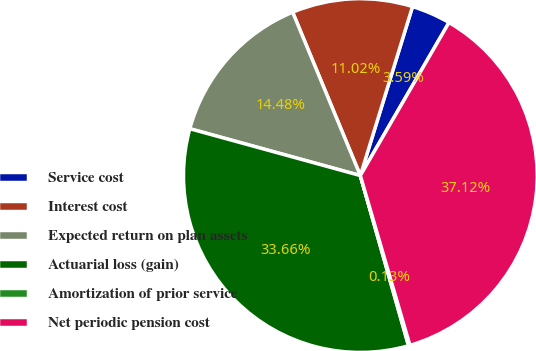Convert chart to OTSL. <chart><loc_0><loc_0><loc_500><loc_500><pie_chart><fcel>Service cost<fcel>Interest cost<fcel>Expected return on plan assets<fcel>Actuarial loss (gain)<fcel>Amortization of prior service<fcel>Net periodic pension cost<nl><fcel>3.59%<fcel>11.02%<fcel>14.48%<fcel>33.66%<fcel>0.13%<fcel>37.12%<nl></chart> 